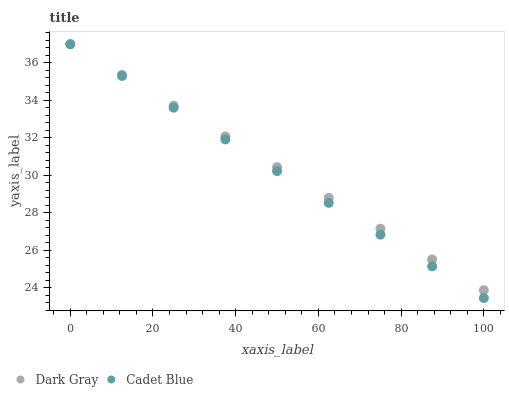Does Cadet Blue have the minimum area under the curve?
Answer yes or no. Yes. Does Dark Gray have the maximum area under the curve?
Answer yes or no. Yes. Does Cadet Blue have the maximum area under the curve?
Answer yes or no. No. Is Dark Gray the smoothest?
Answer yes or no. Yes. Is Cadet Blue the roughest?
Answer yes or no. Yes. Is Cadet Blue the smoothest?
Answer yes or no. No. Does Cadet Blue have the lowest value?
Answer yes or no. Yes. Does Cadet Blue have the highest value?
Answer yes or no. Yes. Does Cadet Blue intersect Dark Gray?
Answer yes or no. Yes. Is Cadet Blue less than Dark Gray?
Answer yes or no. No. Is Cadet Blue greater than Dark Gray?
Answer yes or no. No. 